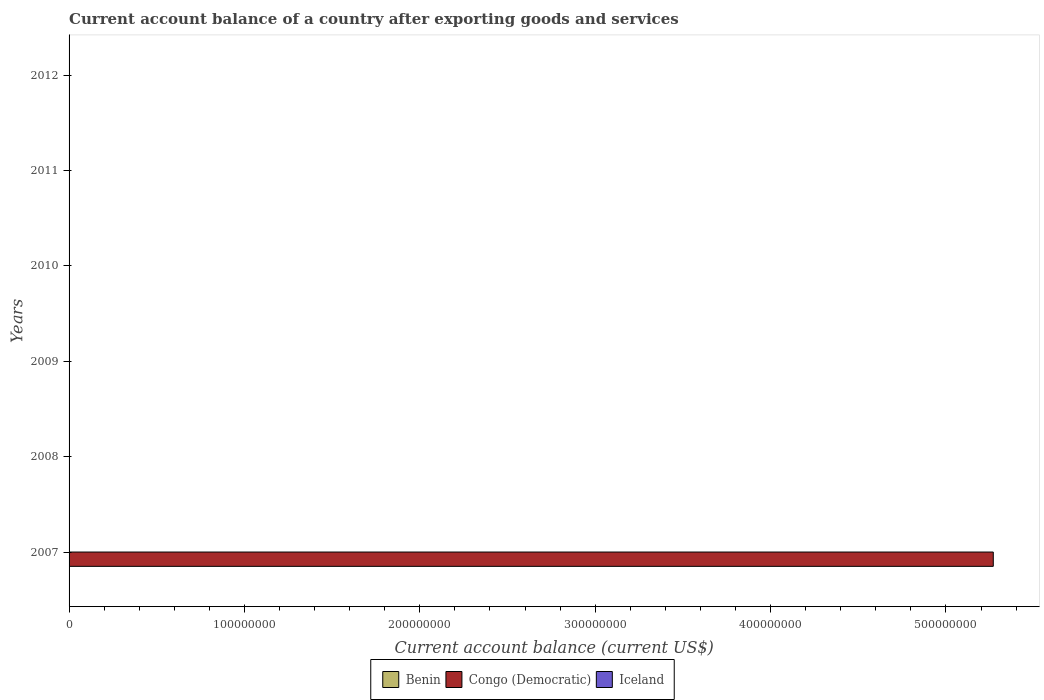Are the number of bars per tick equal to the number of legend labels?
Keep it short and to the point. No. Are the number of bars on each tick of the Y-axis equal?
Keep it short and to the point. No. How many bars are there on the 5th tick from the bottom?
Your response must be concise. 0. What is the label of the 3rd group of bars from the top?
Your answer should be very brief. 2010. In how many cases, is the number of bars for a given year not equal to the number of legend labels?
Keep it short and to the point. 6. Across all years, what is the maximum account balance in Congo (Democratic)?
Provide a succinct answer. 5.27e+08. Across all years, what is the minimum account balance in Congo (Democratic)?
Offer a very short reply. 0. What is the total account balance in Congo (Democratic) in the graph?
Ensure brevity in your answer.  5.27e+08. What is the difference between the account balance in Iceland in 2010 and the account balance in Benin in 2007?
Offer a terse response. 0. What is the average account balance in Congo (Democratic) per year?
Make the answer very short. 8.78e+07. In how many years, is the account balance in Congo (Democratic) greater than 360000000 US$?
Your answer should be compact. 1. What is the difference between the highest and the lowest account balance in Congo (Democratic)?
Ensure brevity in your answer.  5.27e+08. In how many years, is the account balance in Congo (Democratic) greater than the average account balance in Congo (Democratic) taken over all years?
Ensure brevity in your answer.  1. Is it the case that in every year, the sum of the account balance in Benin and account balance in Iceland is greater than the account balance in Congo (Democratic)?
Give a very brief answer. No. How many bars are there?
Make the answer very short. 1. Does the graph contain grids?
Keep it short and to the point. No. Where does the legend appear in the graph?
Provide a succinct answer. Bottom center. How many legend labels are there?
Provide a succinct answer. 3. What is the title of the graph?
Your response must be concise. Current account balance of a country after exporting goods and services. Does "Romania" appear as one of the legend labels in the graph?
Your response must be concise. No. What is the label or title of the X-axis?
Your answer should be compact. Current account balance (current US$). What is the Current account balance (current US$) of Congo (Democratic) in 2007?
Ensure brevity in your answer.  5.27e+08. What is the Current account balance (current US$) of Iceland in 2007?
Provide a succinct answer. 0. What is the Current account balance (current US$) in Benin in 2008?
Your response must be concise. 0. What is the Current account balance (current US$) of Congo (Democratic) in 2008?
Provide a short and direct response. 0. What is the Current account balance (current US$) of Benin in 2009?
Ensure brevity in your answer.  0. What is the Current account balance (current US$) of Congo (Democratic) in 2009?
Your answer should be compact. 0. What is the Current account balance (current US$) of Congo (Democratic) in 2010?
Ensure brevity in your answer.  0. What is the Current account balance (current US$) in Benin in 2011?
Ensure brevity in your answer.  0. What is the Current account balance (current US$) in Congo (Democratic) in 2011?
Offer a terse response. 0. What is the Current account balance (current US$) of Iceland in 2011?
Keep it short and to the point. 0. What is the Current account balance (current US$) of Benin in 2012?
Offer a very short reply. 0. What is the Current account balance (current US$) in Congo (Democratic) in 2012?
Your answer should be compact. 0. Across all years, what is the maximum Current account balance (current US$) in Congo (Democratic)?
Provide a succinct answer. 5.27e+08. What is the total Current account balance (current US$) of Benin in the graph?
Ensure brevity in your answer.  0. What is the total Current account balance (current US$) in Congo (Democratic) in the graph?
Provide a succinct answer. 5.27e+08. What is the average Current account balance (current US$) of Congo (Democratic) per year?
Offer a terse response. 8.78e+07. What is the difference between the highest and the lowest Current account balance (current US$) of Congo (Democratic)?
Give a very brief answer. 5.27e+08. 